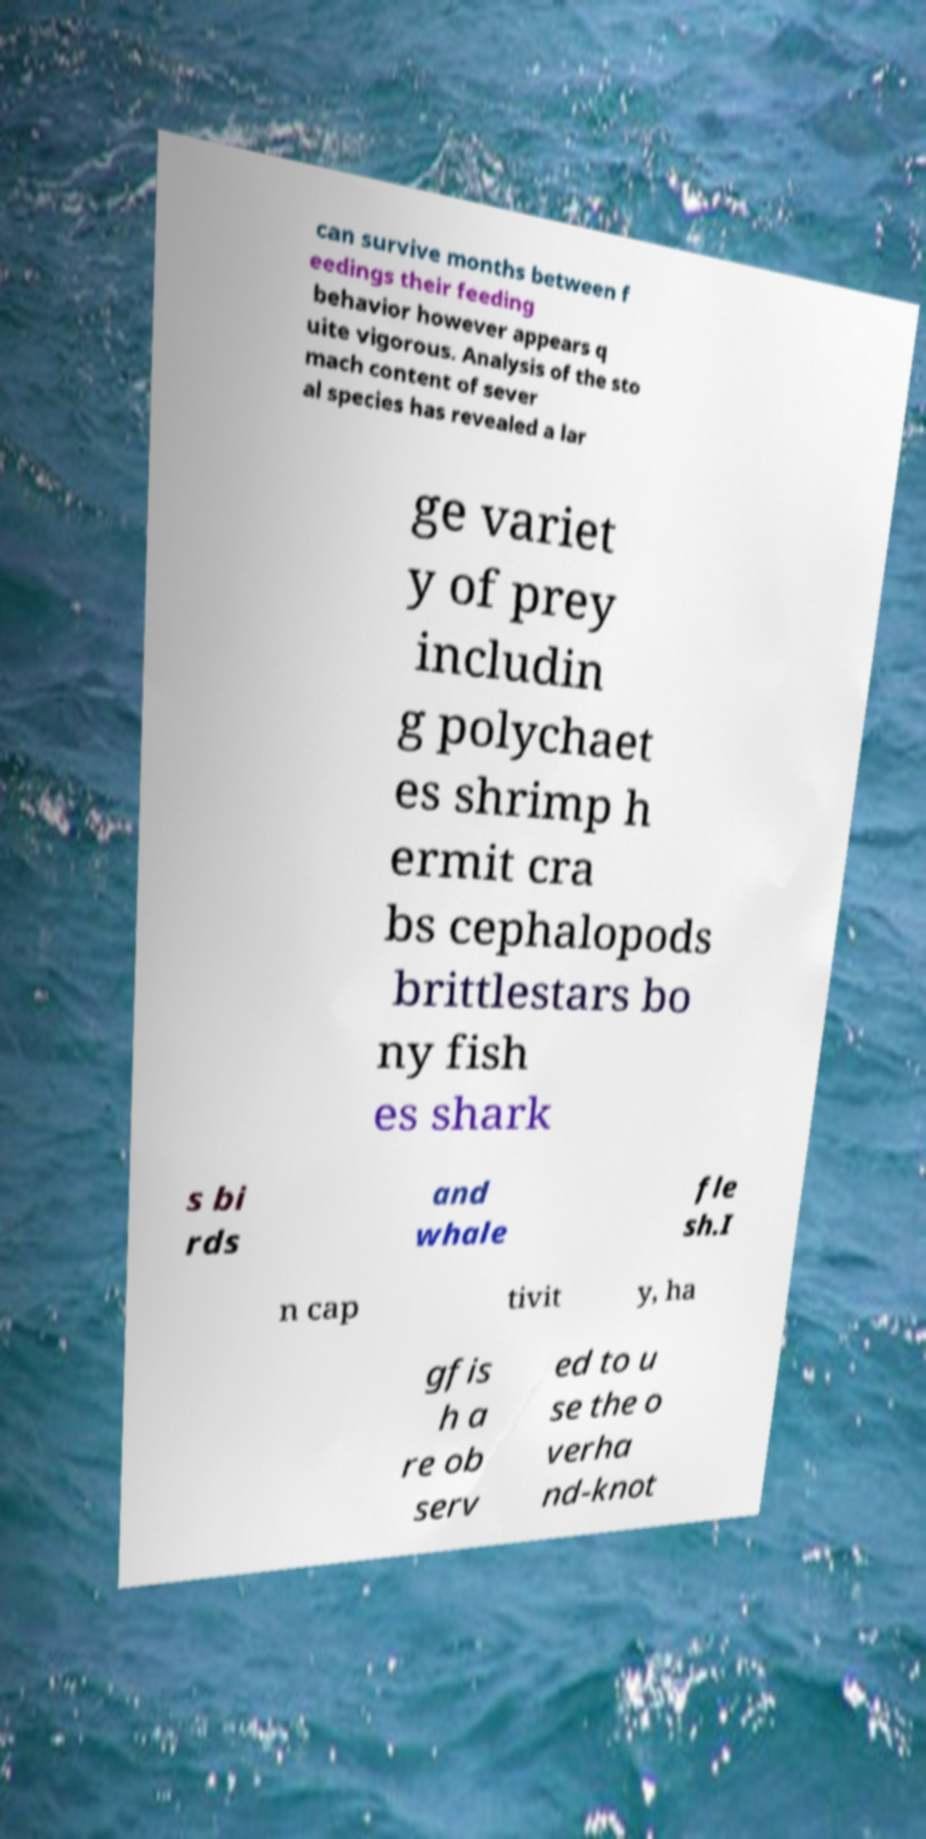Could you assist in decoding the text presented in this image and type it out clearly? can survive months between f eedings their feeding behavior however appears q uite vigorous. Analysis of the sto mach content of sever al species has revealed a lar ge variet y of prey includin g polychaet es shrimp h ermit cra bs cephalopods brittlestars bo ny fish es shark s bi rds and whale fle sh.I n cap tivit y, ha gfis h a re ob serv ed to u se the o verha nd-knot 